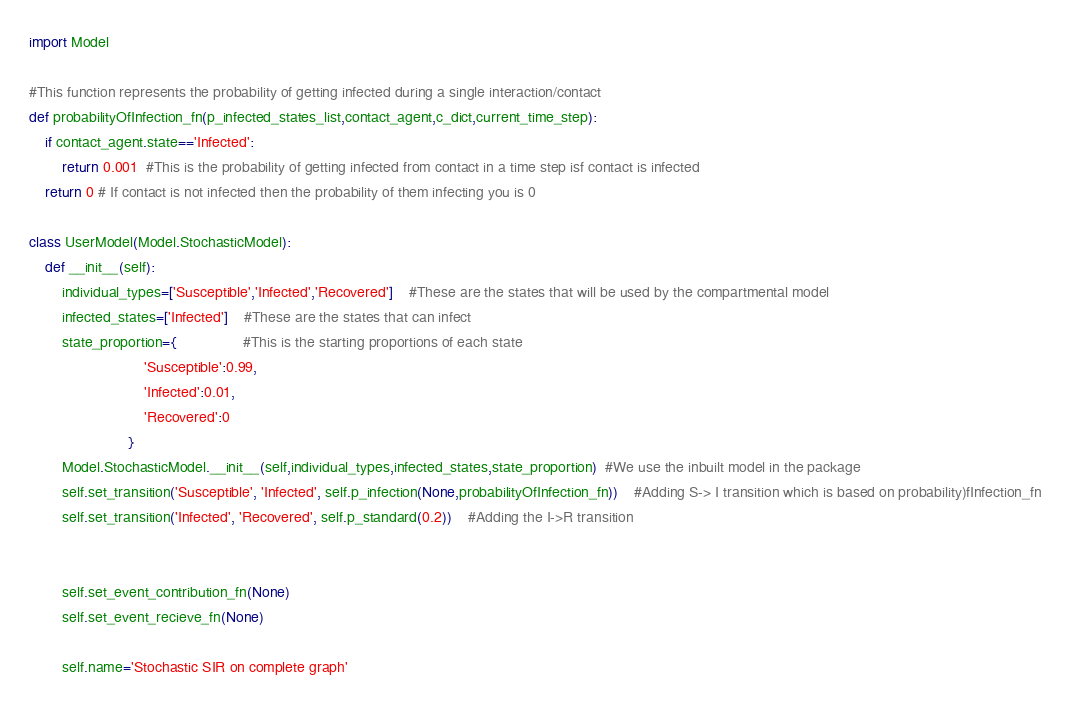<code> <loc_0><loc_0><loc_500><loc_500><_Python_>import Model

#This function represents the probability of getting infected during a single interaction/contact
def probabilityOfInfection_fn(p_infected_states_list,contact_agent,c_dict,current_time_step):
	if contact_agent.state=='Infected':
		return 0.001  #This is the probability of getting infected from contact in a time step isf contact is infected
	return 0 # If contact is not infected then the probability of them infecting you is 0

class UserModel(Model.StochasticModel):
	def __init__(self):
		individual_types=['Susceptible','Infected','Recovered']	#These are the states that will be used by the compartmental model
		infected_states=['Infected']	#These are the states that can infect 
		state_proportion={				#This is the starting proportions of each state
							'Susceptible':0.99,
							'Infected':0.01,
							'Recovered':0
						}
		Model.StochasticModel.__init__(self,individual_types,infected_states,state_proportion)  #We use the inbuilt model in the package
		self.set_transition('Susceptible', 'Infected', self.p_infection(None,probabilityOfInfection_fn))	#Adding S-> I transition which is based on probability)fInfection_fn
		self.set_transition('Infected', 'Recovered', self.p_standard(0.2))	#Adding the I->R transition


		self.set_event_contribution_fn(None)	
		self.set_event_recieve_fn(None)	

		self.name='Stochastic SIR on complete graph'</code> 